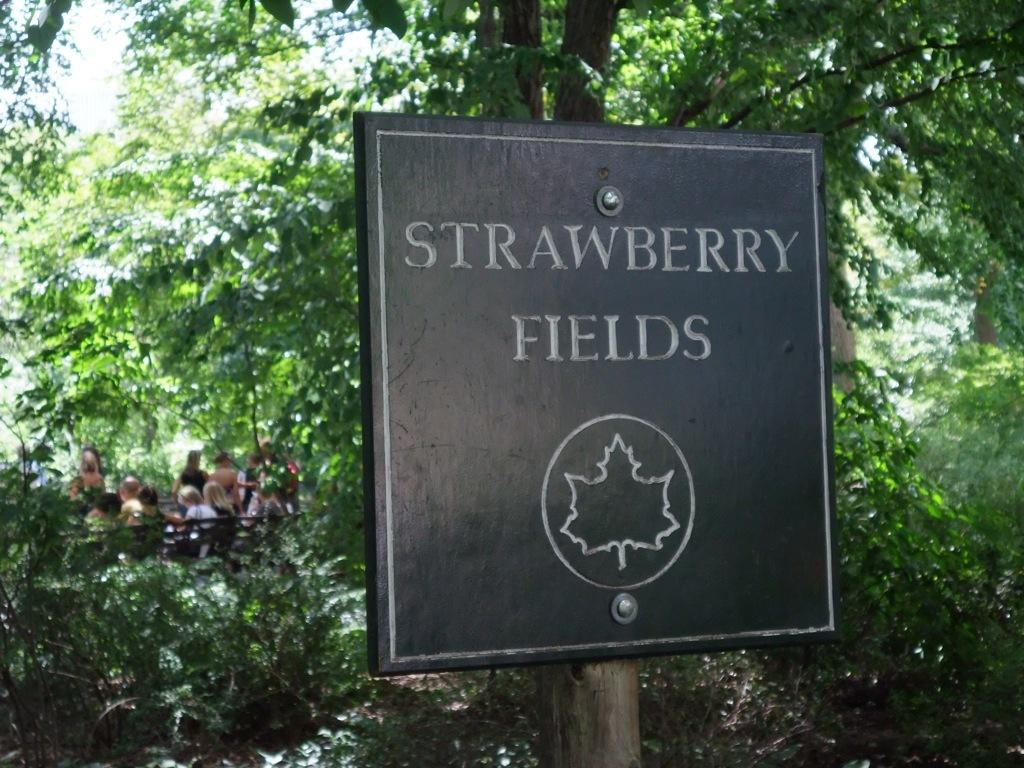What is the main object in the middle of the image? There is a noticeboard in the middle of the image. What can be seen in the background of the image? There are trees and a group of people in the background of the image. What are some people doing in the image? Some people are seated on a bench, and some people are standing. Can you see a maid walking a snake in the image? No, there is no maid or snake present in the image. 